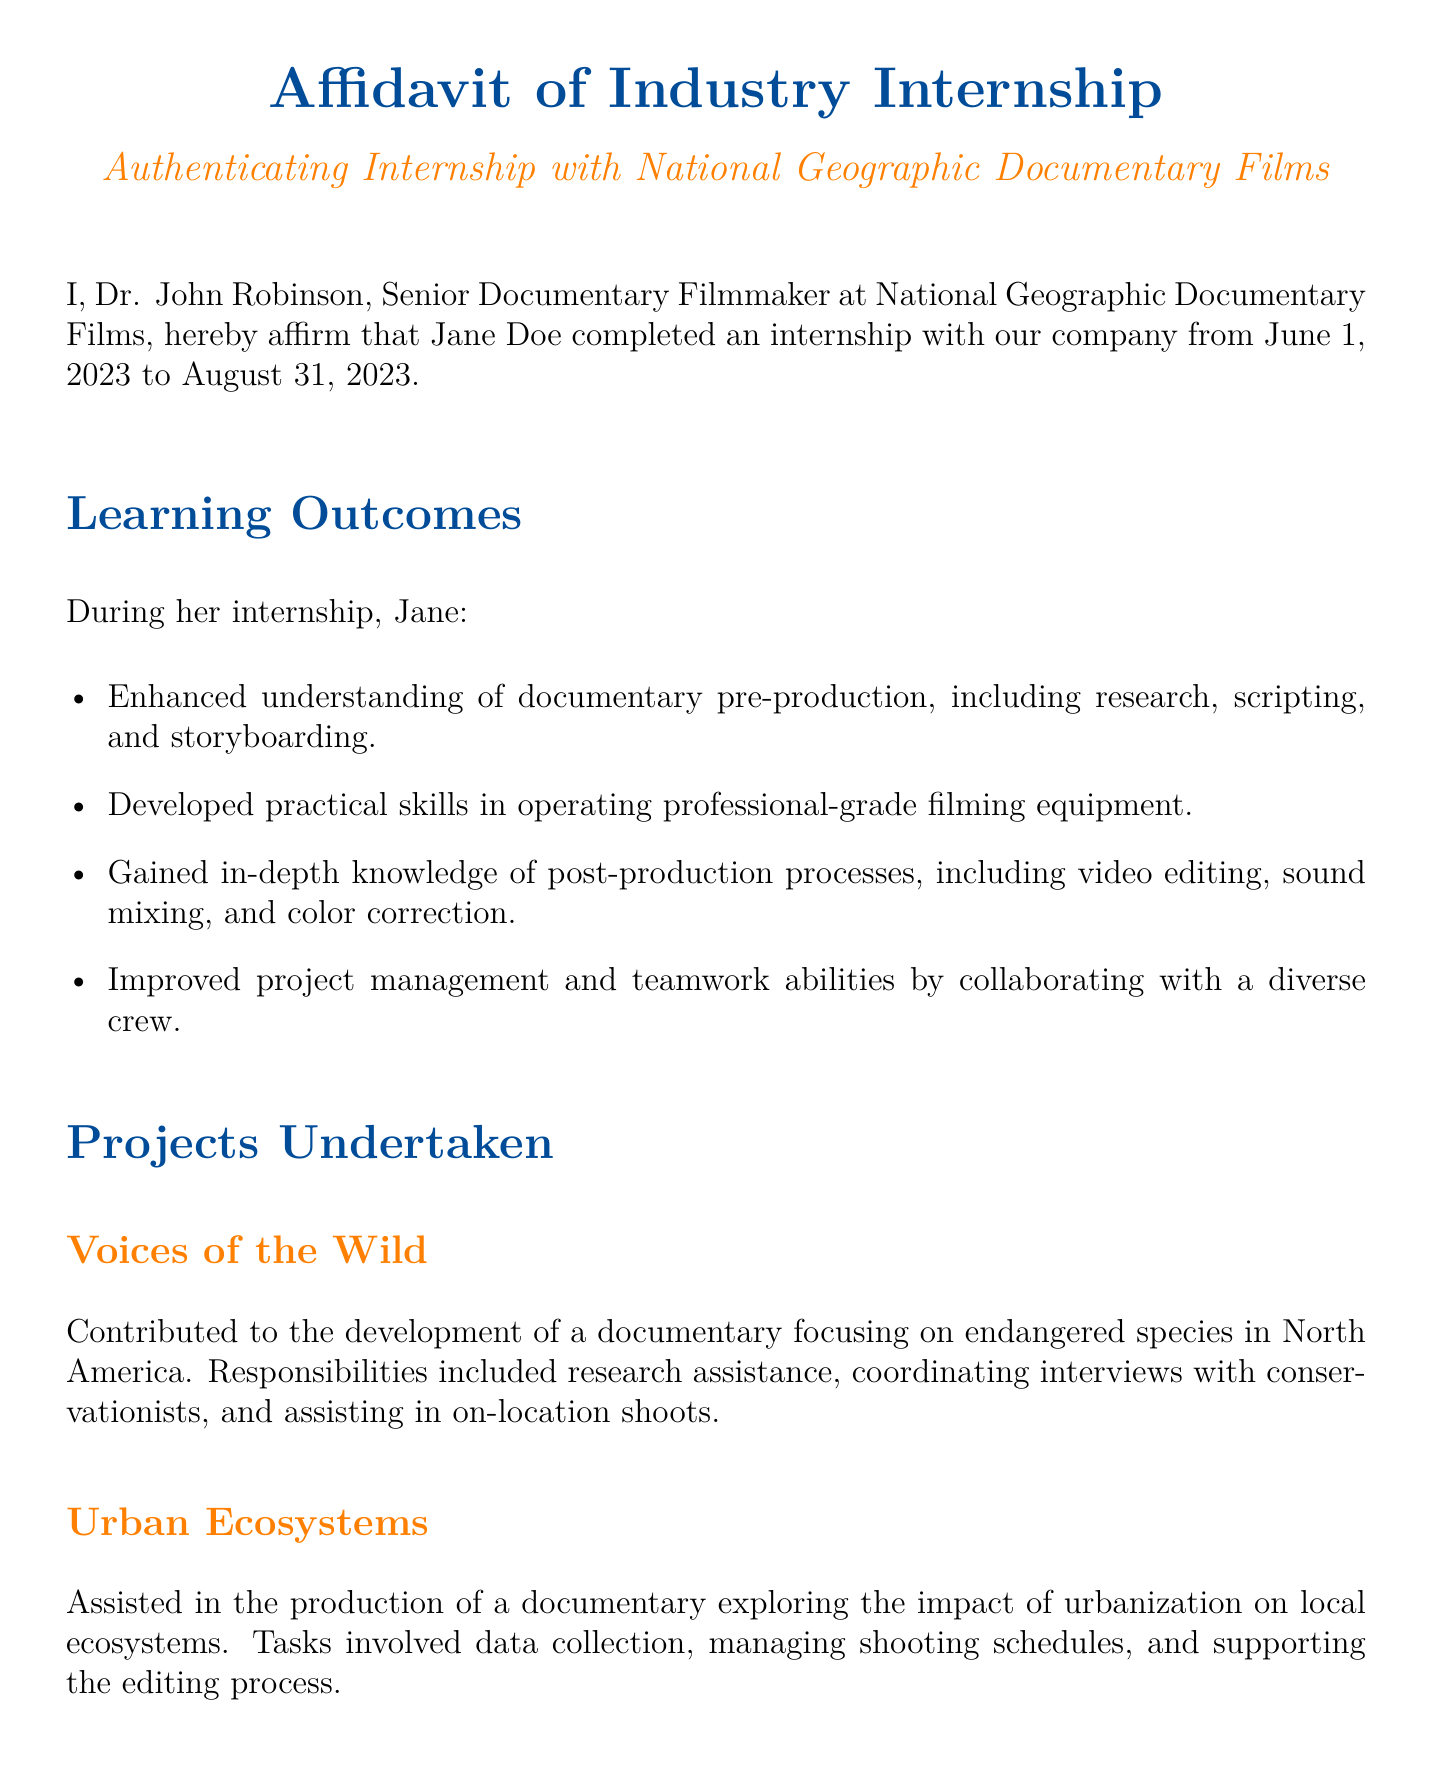What is the name of the intern? The intern's name is clearly stated at the beginning of the document.
Answer: Jane Doe What is the name of the company? The name of the company is provided in the document title.
Answer: National Geographic Documentary Films What is the internship start date? The start date can be found in the second line of the document.
Answer: June 1, 2023 What is the end date of the internship? The end date is mentioned in the second line of the document after the start date.
Answer: August 31, 2023 How many main projects are listed in the document? The document lists three specific projects undertaken during the internship.
Answer: Three Who is the signatory of the affidavit? The person's name who signed the affidavit appears at the bottom of the document.
Answer: Dr. John Robinson What was one of the skills Jane improved during her internship? The document lists several skills gained during the internship in a section.
Answer: Project management What is the title of the first project mentioned? The title of the first project is specified in its subsection heading.
Answer: Voices of the Wild What type of document is this? The document begins with a clear title indicating its nature.
Answer: Affidavit 